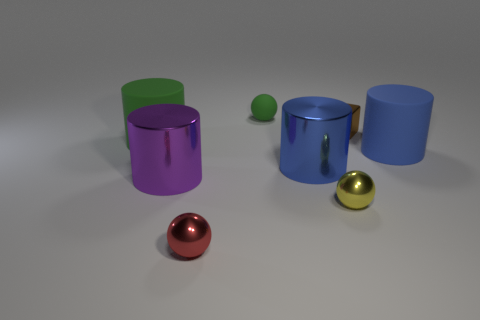Can you suggest what kind of light source was used, based on the shadows and highlights? The shadows and highlights on the objects indicate that there's a single, diffuse light source coming from the upper left side of the image. This light source casts soft-edged shadows toward the right, which suggests it could be an overcast sky or a large light diffuser used in photography to create a soft illumination. 